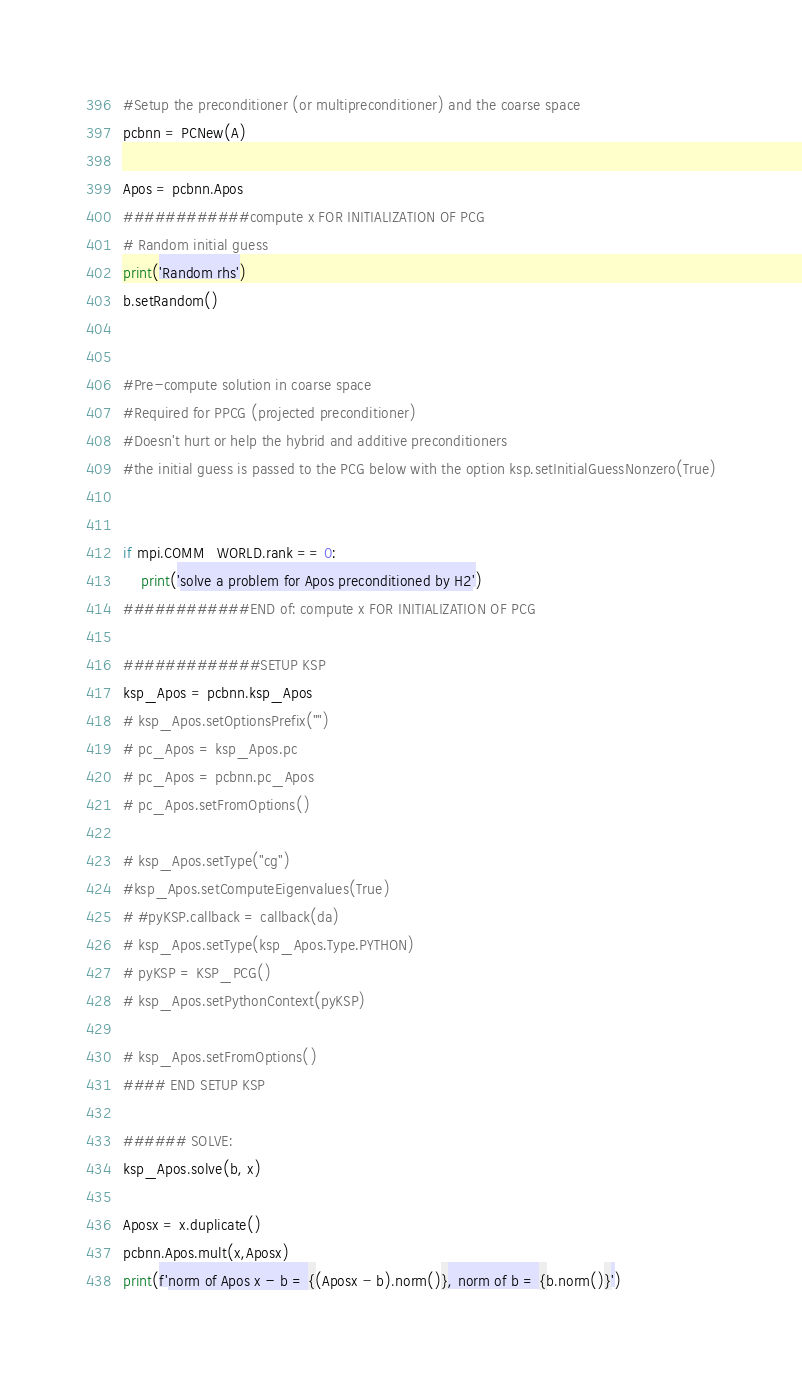<code> <loc_0><loc_0><loc_500><loc_500><_Python_>
#Setup the preconditioner (or multipreconditioner) and the coarse space
pcbnn = PCNew(A)

Apos = pcbnn.Apos
############compute x FOR INITIALIZATION OF PCG
# Random initial guess
print('Random rhs')
b.setRandom()


#Pre-compute solution in coarse space
#Required for PPCG (projected preconditioner)
#Doesn't hurt or help the hybrid and additive preconditioners
#the initial guess is passed to the PCG below with the option ksp.setInitialGuessNonzero(True)


if mpi.COMM_WORLD.rank == 0:
    print('solve a problem for Apos preconditioned by H2')
############END of: compute x FOR INITIALIZATION OF PCG

#############SETUP KSP
ksp_Apos = pcbnn.ksp_Apos
# ksp_Apos.setOptionsPrefix("")
# pc_Apos = ksp_Apos.pc
# pc_Apos = pcbnn.pc_Apos
# pc_Apos.setFromOptions()

# ksp_Apos.setType("cg")
#ksp_Apos.setComputeEigenvalues(True)
# #pyKSP.callback = callback(da)
# ksp_Apos.setType(ksp_Apos.Type.PYTHON)
# pyKSP = KSP_PCG()
# ksp_Apos.setPythonContext(pyKSP)

# ksp_Apos.setFromOptions()
#### END SETUP KSP

###### SOLVE:
ksp_Apos.solve(b, x)

Aposx = x.duplicate()
pcbnn.Apos.mult(x,Aposx)
print(f'norm of Apos x - b = {(Aposx - b).norm()}, norm of b = {b.norm()}')

</code> 